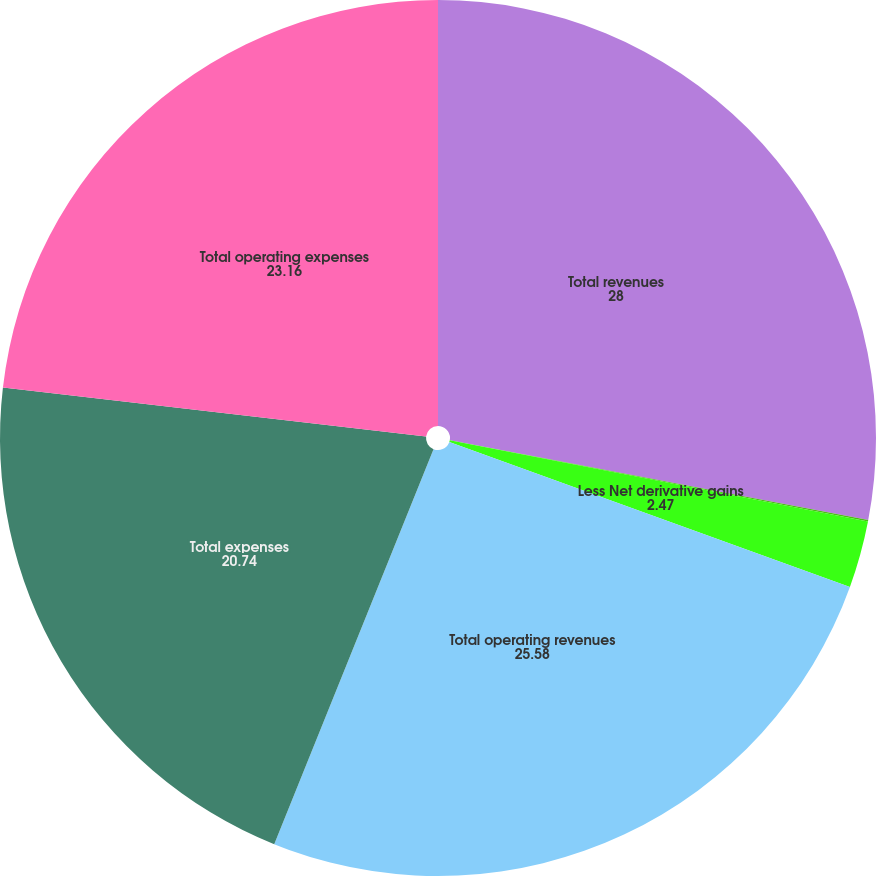Convert chart. <chart><loc_0><loc_0><loc_500><loc_500><pie_chart><fcel>Total revenues<fcel>Less Net investment gains<fcel>Less Net derivative gains<fcel>Total operating revenues<fcel>Total expenses<fcel>Total operating expenses<nl><fcel>28.0%<fcel>0.05%<fcel>2.47%<fcel>25.58%<fcel>20.74%<fcel>23.16%<nl></chart> 